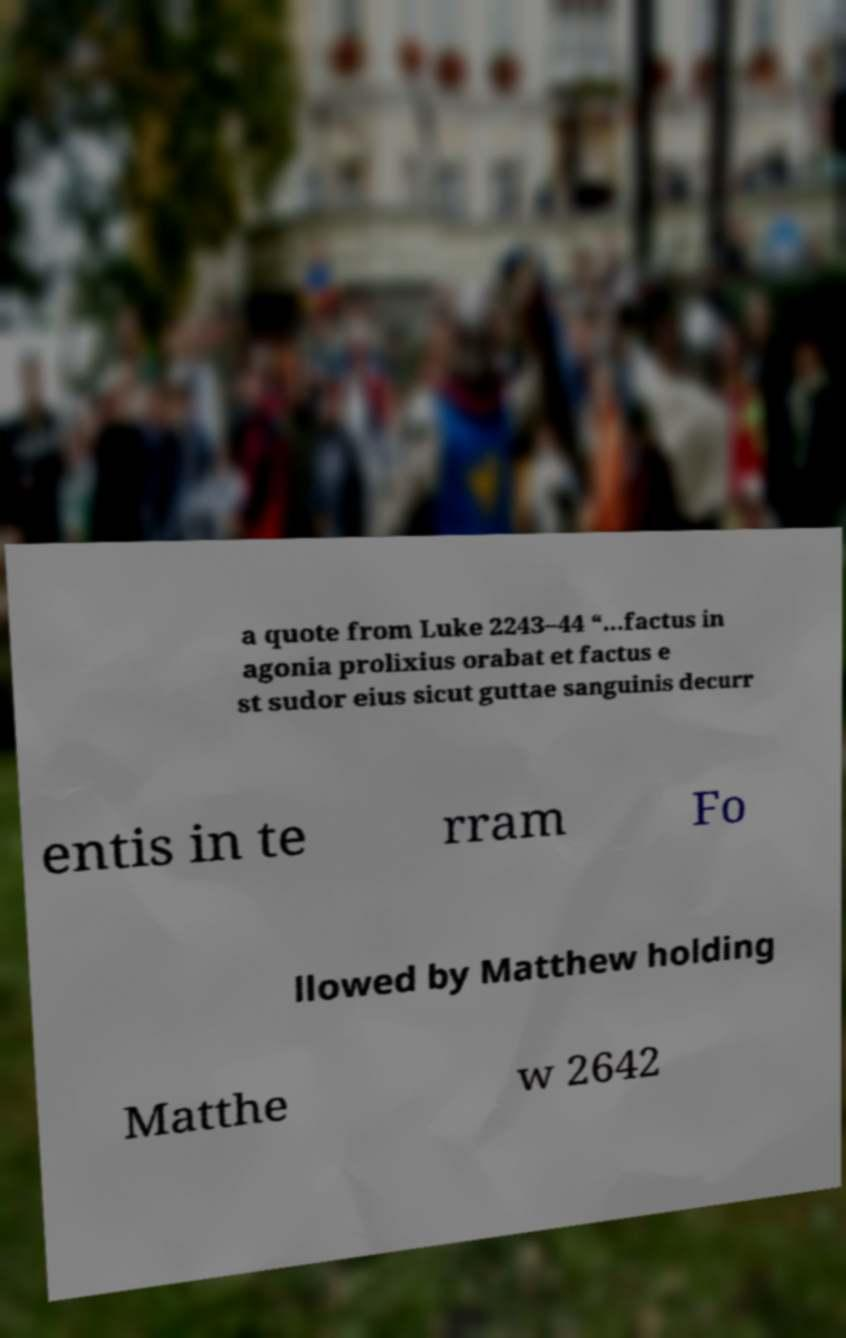For documentation purposes, I need the text within this image transcribed. Could you provide that? a quote from Luke 2243–44 “…factus in agonia prolixius orabat et factus e st sudor eius sicut guttae sanguinis decurr entis in te rram Fo llowed by Matthew holding Matthe w 2642 